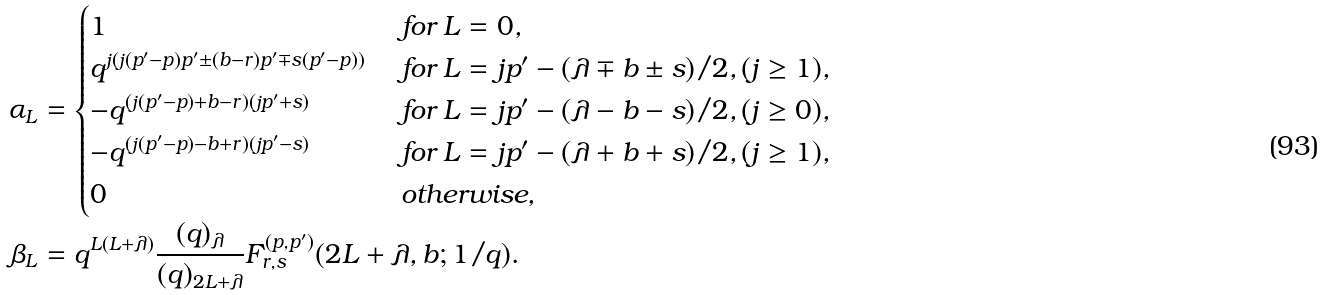<formula> <loc_0><loc_0><loc_500><loc_500>\alpha _ { L } & = \begin{cases} 1 & \text { for } L = 0 , \\ q ^ { j ( j ( p ^ { \prime } - p ) p ^ { \prime } \pm ( b - r ) p ^ { \prime } \mp s ( p ^ { \prime } - p ) ) } & \text { for } L = j p ^ { \prime } - ( \lambda \mp b \pm s ) / 2 , ( j \geq 1 ) , \\ - q ^ { ( j ( p ^ { \prime } - p ) + b - r ) ( j p ^ { \prime } + s ) } & \text { for } L = j p ^ { \prime } - ( \lambda - b - s ) / 2 , ( j \geq 0 ) , \\ - q ^ { ( j ( p ^ { \prime } - p ) - b + r ) ( j p ^ { \prime } - s ) } & \text { for } L = j p ^ { \prime } - ( \lambda + b + s ) / 2 , ( j \geq 1 ) , \\ 0 & \text { otherwise} , \end{cases} \\ \beta _ { L } & = q ^ { L ( L + \lambda ) } \frac { ( q ) _ { \lambda } } { ( q ) _ { 2 L + \lambda } } F ^ { ( p , p ^ { \prime } ) } _ { r , s } ( 2 L + \lambda , b ; 1 / q ) .</formula> 